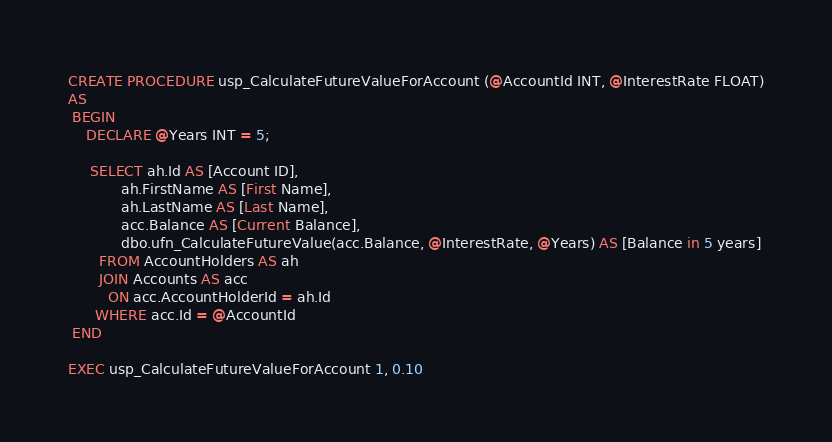<code> <loc_0><loc_0><loc_500><loc_500><_SQL_>CREATE PROCEDURE usp_CalculateFutureValueForAccount (@AccountId INT, @InterestRate FLOAT)
AS
 BEGIN
	DECLARE @Years INT = 5;

	 SELECT ah.Id AS [Account ID],
			ah.FirstName AS [First Name],
			ah.LastName AS [Last Name],
			acc.Balance AS [Current Balance],
			dbo.ufn_CalculateFutureValue(acc.Balance, @InterestRate, @Years) AS [Balance in 5 years]
	   FROM AccountHolders AS ah
	   JOIN Accounts AS acc
	     ON acc.AccountHolderId = ah.Id
	  WHERE acc.Id = @AccountId
 END

EXEC usp_CalculateFutureValueForAccount 1, 0.10</code> 